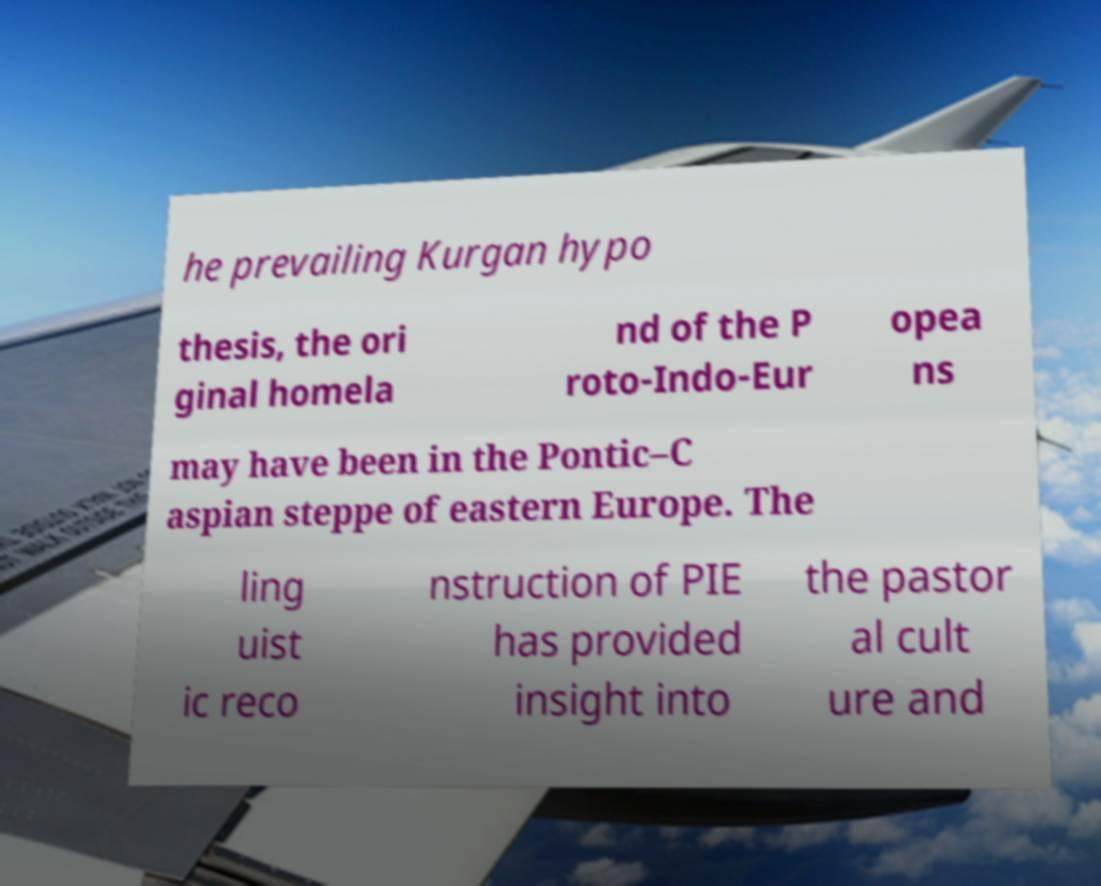What messages or text are displayed in this image? I need them in a readable, typed format. he prevailing Kurgan hypo thesis, the ori ginal homela nd of the P roto-Indo-Eur opea ns may have been in the Pontic–C aspian steppe of eastern Europe. The ling uist ic reco nstruction of PIE has provided insight into the pastor al cult ure and 